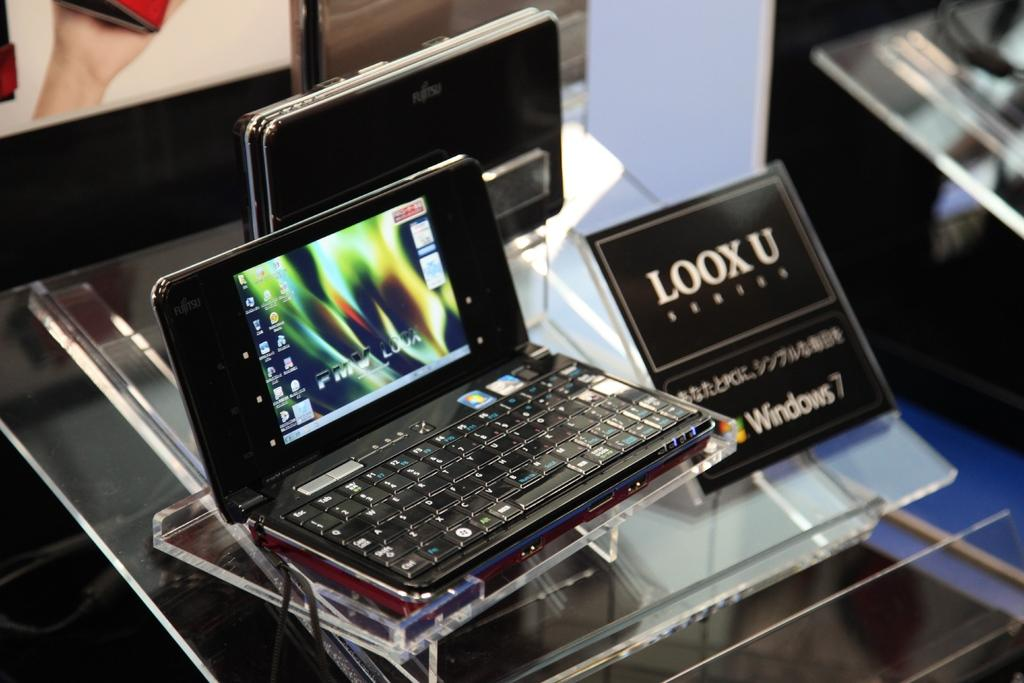<image>
Write a terse but informative summary of the picture. A tablet made by LOOX U running Windows 7. 